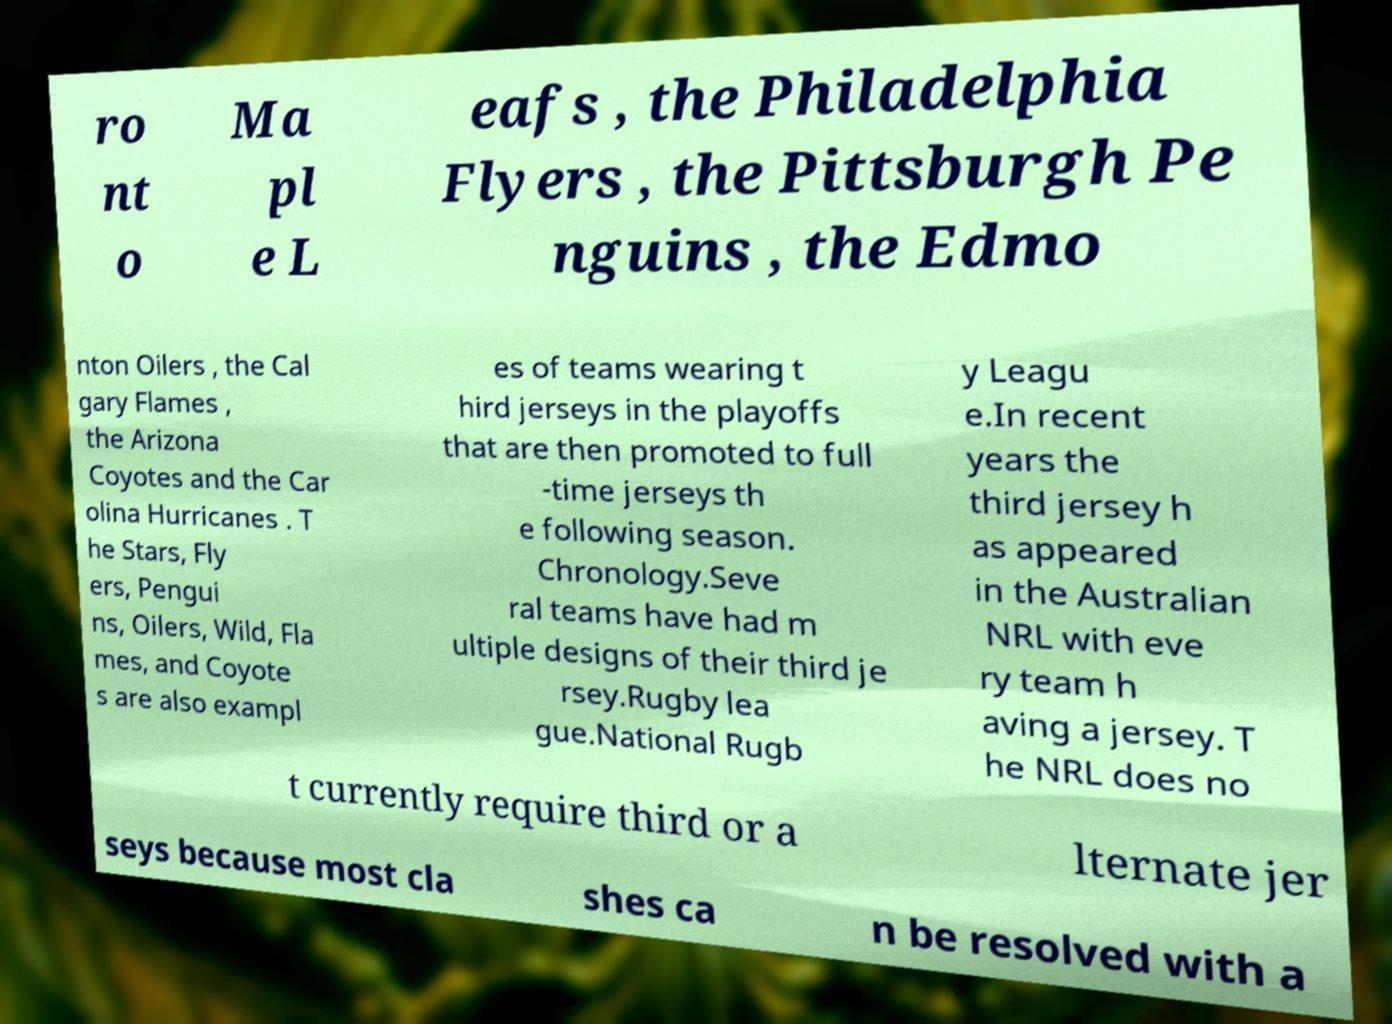Please identify and transcribe the text found in this image. ro nt o Ma pl e L eafs , the Philadelphia Flyers , the Pittsburgh Pe nguins , the Edmo nton Oilers , the Cal gary Flames , the Arizona Coyotes and the Car olina Hurricanes . T he Stars, Fly ers, Pengui ns, Oilers, Wild, Fla mes, and Coyote s are also exampl es of teams wearing t hird jerseys in the playoffs that are then promoted to full -time jerseys th e following season. Chronology.Seve ral teams have had m ultiple designs of their third je rsey.Rugby lea gue.National Rugb y Leagu e.In recent years the third jersey h as appeared in the Australian NRL with eve ry team h aving a jersey. T he NRL does no t currently require third or a lternate jer seys because most cla shes ca n be resolved with a 